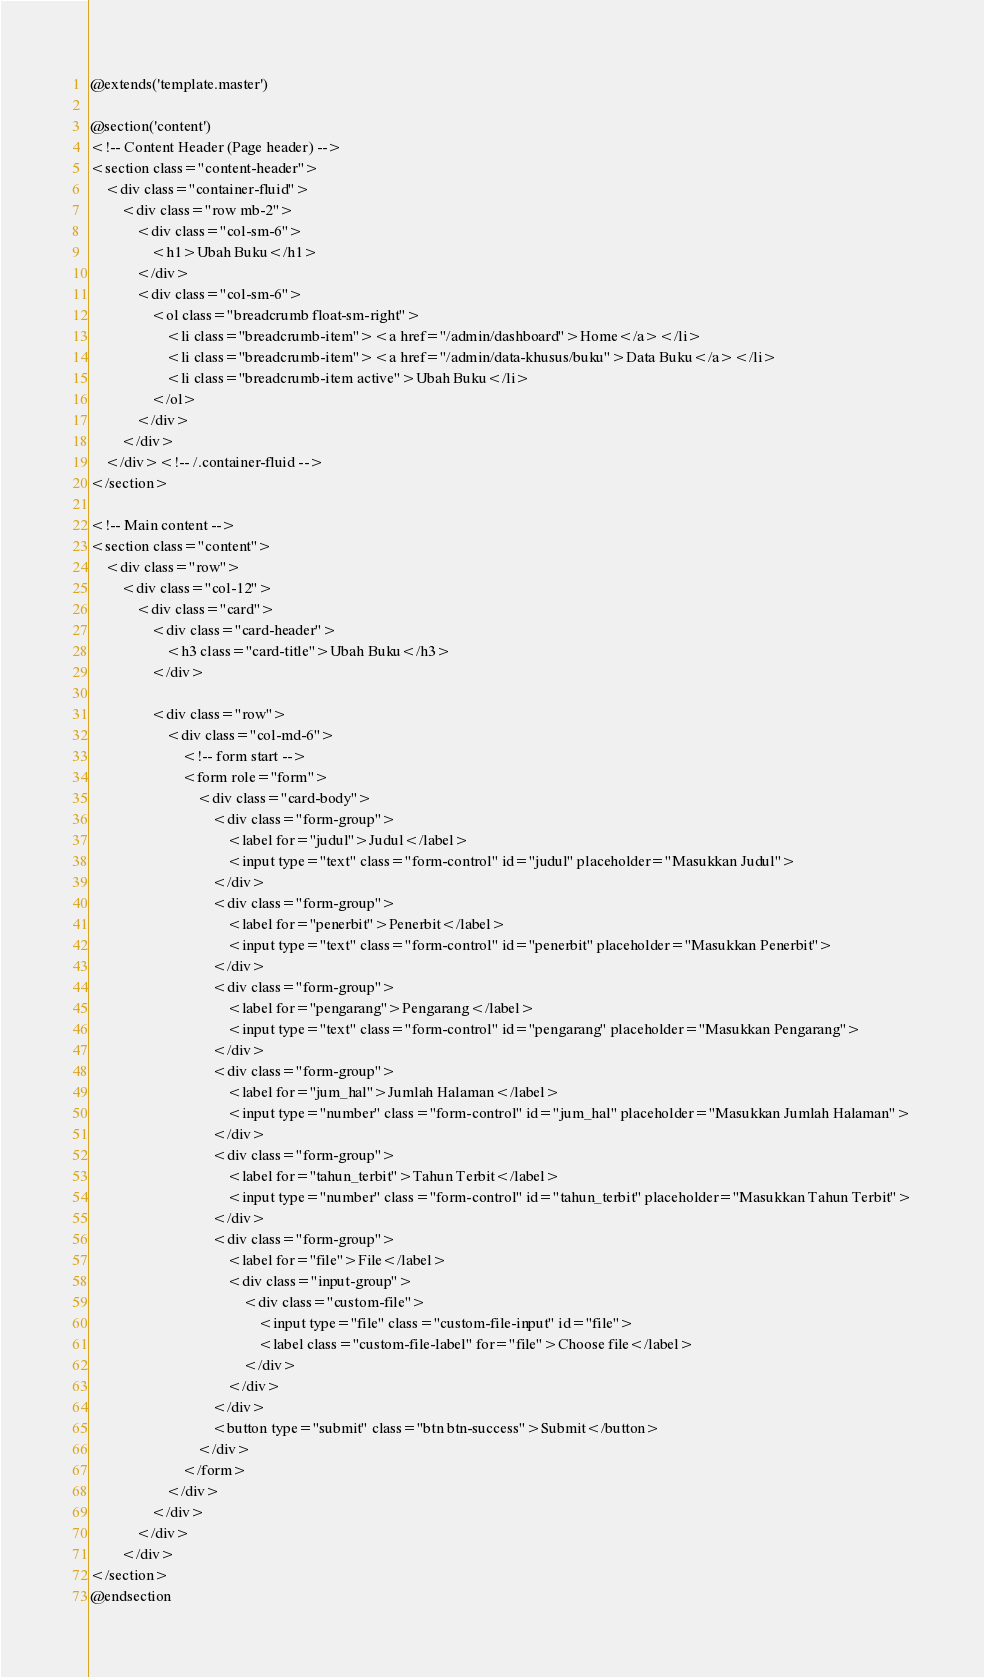<code> <loc_0><loc_0><loc_500><loc_500><_PHP_>@extends('template.master')

@section('content')
<!-- Content Header (Page header) -->
<section class="content-header">
    <div class="container-fluid">
        <div class="row mb-2">
            <div class="col-sm-6">
                <h1>Ubah Buku</h1>
            </div>
            <div class="col-sm-6">
                <ol class="breadcrumb float-sm-right">
                    <li class="breadcrumb-item"><a href="/admin/dashboard">Home</a></li>
                    <li class="breadcrumb-item"><a href="/admin/data-khusus/buku">Data Buku</a></li>
                    <li class="breadcrumb-item active">Ubah Buku</li>
                </ol>
            </div>
        </div>
    </div><!-- /.container-fluid -->
</section>

<!-- Main content -->
<section class="content">
    <div class="row">
        <div class="col-12">
            <div class="card">
                <div class="card-header">
                    <h3 class="card-title">Ubah Buku</h3>
                </div>

                <div class="row">
                    <div class="col-md-6">
                        <!-- form start -->
                        <form role="form">
                            <div class="card-body">
                                <div class="form-group">
                                    <label for="judul">Judul</label>
                                    <input type="text" class="form-control" id="judul" placeholder="Masukkan Judul">
                                </div>
                                <div class="form-group">
                                    <label for="penerbit">Penerbit</label>
                                    <input type="text" class="form-control" id="penerbit" placeholder="Masukkan Penerbit">
                                </div>
                                <div class="form-group">
                                    <label for="pengarang">Pengarang</label>
                                    <input type="text" class="form-control" id="pengarang" placeholder="Masukkan Pengarang">
                                </div>
                                <div class="form-group">
                                    <label for="jum_hal">Jumlah Halaman</label>
                                    <input type="number" class="form-control" id="jum_hal" placeholder="Masukkan Jumlah Halaman">
                                </div>
                                <div class="form-group">
                                    <label for="tahun_terbit">Tahun Terbit</label>
                                    <input type="number" class="form-control" id="tahun_terbit" placeholder="Masukkan Tahun Terbit">
                                </div>
                                <div class="form-group">
                                    <label for="file">File</label>
                                    <div class="input-group">
                                        <div class="custom-file">
                                            <input type="file" class="custom-file-input" id="file">
                                            <label class="custom-file-label" for="file">Choose file</label>
                                        </div>
                                    </div>
                                </div>
                                <button type="submit" class="btn btn-success">Submit</button>
                            </div>
                        </form>
                    </div>
                </div>
            </div>
        </div>
</section>
@endsection
</code> 